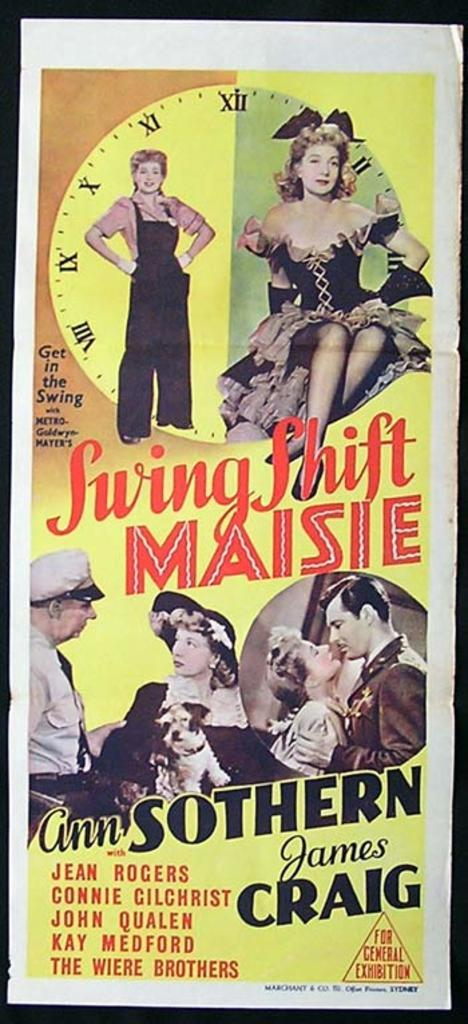<image>
Relay a brief, clear account of the picture shown. A poster for Swing Shift Maisie with James Craig is set on display. 